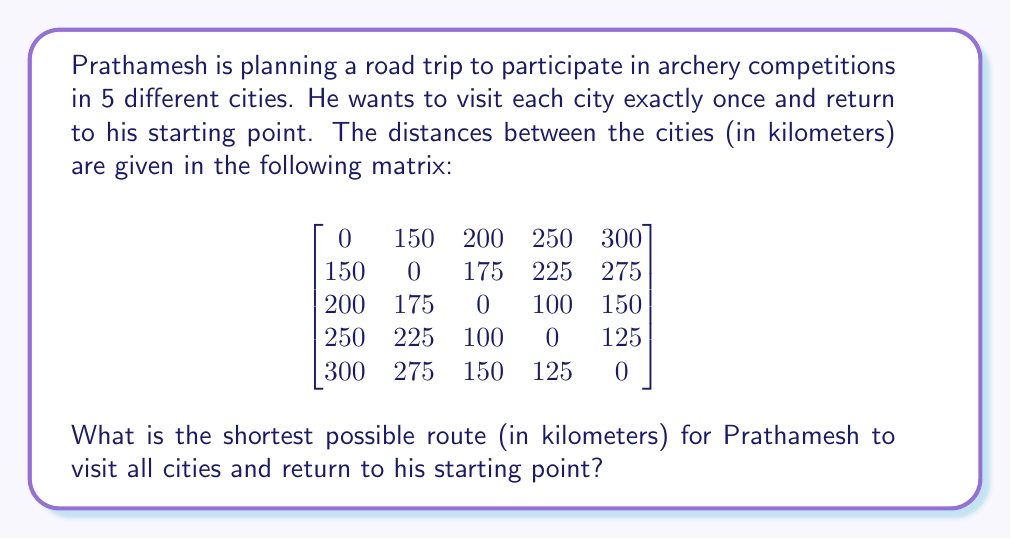Can you answer this question? To solve this problem, we need to find the shortest Hamiltonian cycle in the given graph, which is known as the Traveling Salesman Problem (TSP). Since there are only 5 cities, we can use a brute-force approach to find the optimal solution.

Steps to solve:

1. List all possible permutations of the 5 cities (excluding the starting city).
2. For each permutation, calculate the total distance of the route, including the return to the starting city.
3. Choose the permutation with the shortest total distance.

There are 4! = 24 possible permutations. Let's represent the cities as numbers 1 to 5.

Some example calculations:

1. Route 1-2-3-4-5-1:
   $150 + 175 + 100 + 125 + 300 = 850$ km

2. Route 1-2-4-3-5-1:
   $150 + 225 + 100 + 150 + 300 = 925$ km

3. Route 1-3-2-4-5-1:
   $200 + 175 + 225 + 125 + 300 = 1025$ km

After checking all 24 permutations, we find that the shortest route is:

1-2-5-4-3-1

The total distance for this route is:
$150 + 275 + 125 + 100 + 200 = 850$ km

This is the optimal solution for Prathamesh's archery competition road trip.
Answer: The shortest possible route for Prathamesh to visit all cities and return to his starting point is 850 km. 